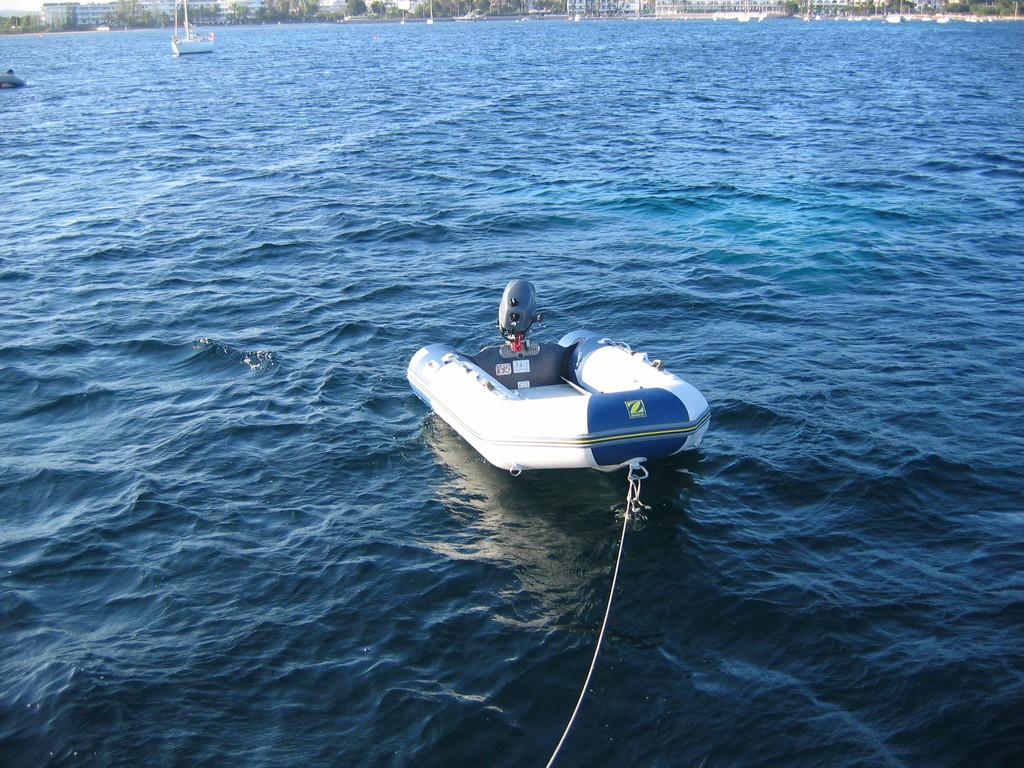What letter is on this boat?
Give a very brief answer. Z. 